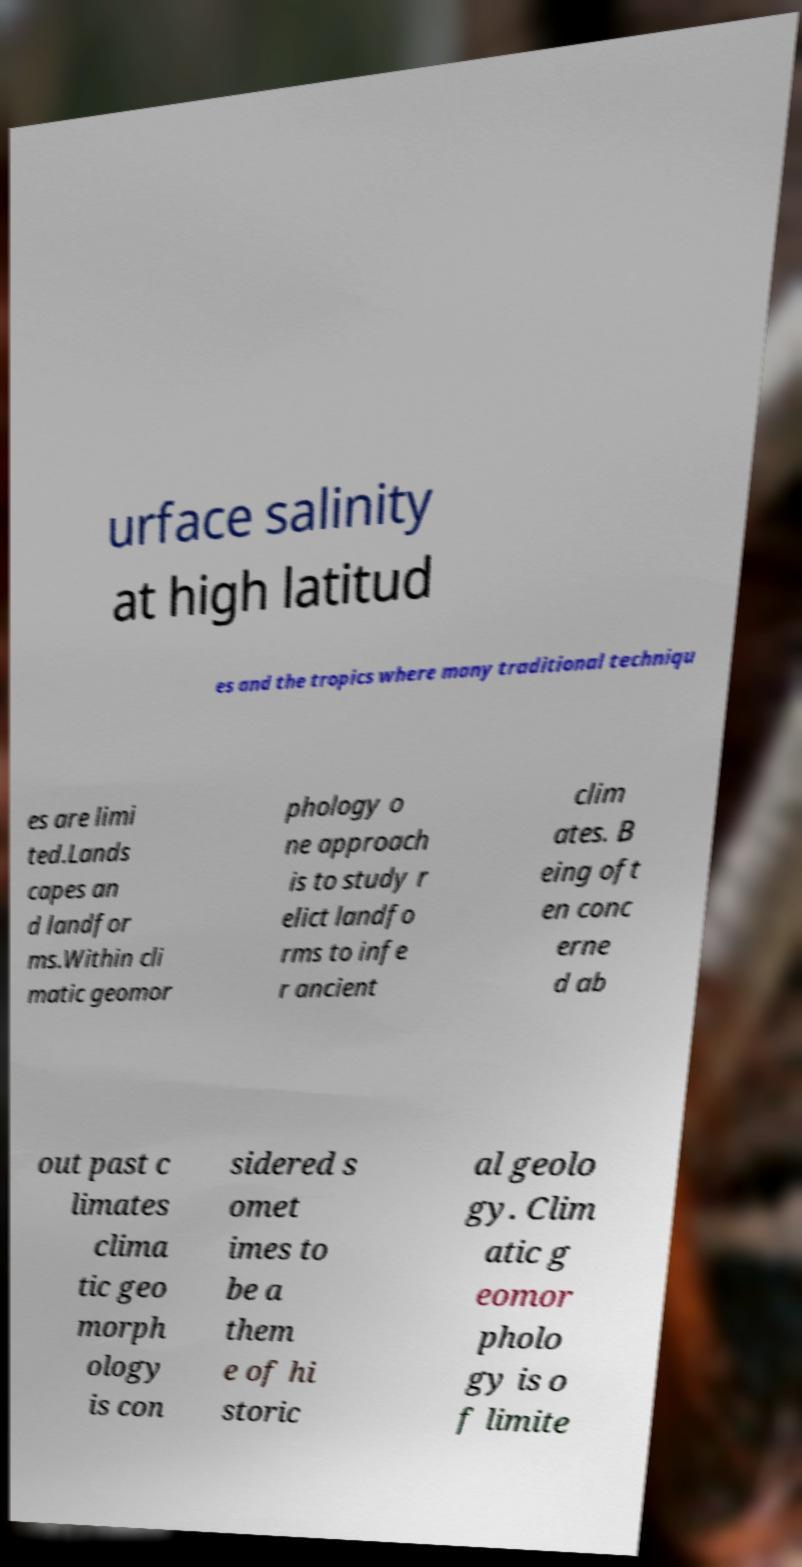Can you accurately transcribe the text from the provided image for me? urface salinity at high latitud es and the tropics where many traditional techniqu es are limi ted.Lands capes an d landfor ms.Within cli matic geomor phology o ne approach is to study r elict landfo rms to infe r ancient clim ates. B eing oft en conc erne d ab out past c limates clima tic geo morph ology is con sidered s omet imes to be a them e of hi storic al geolo gy. Clim atic g eomor pholo gy is o f limite 